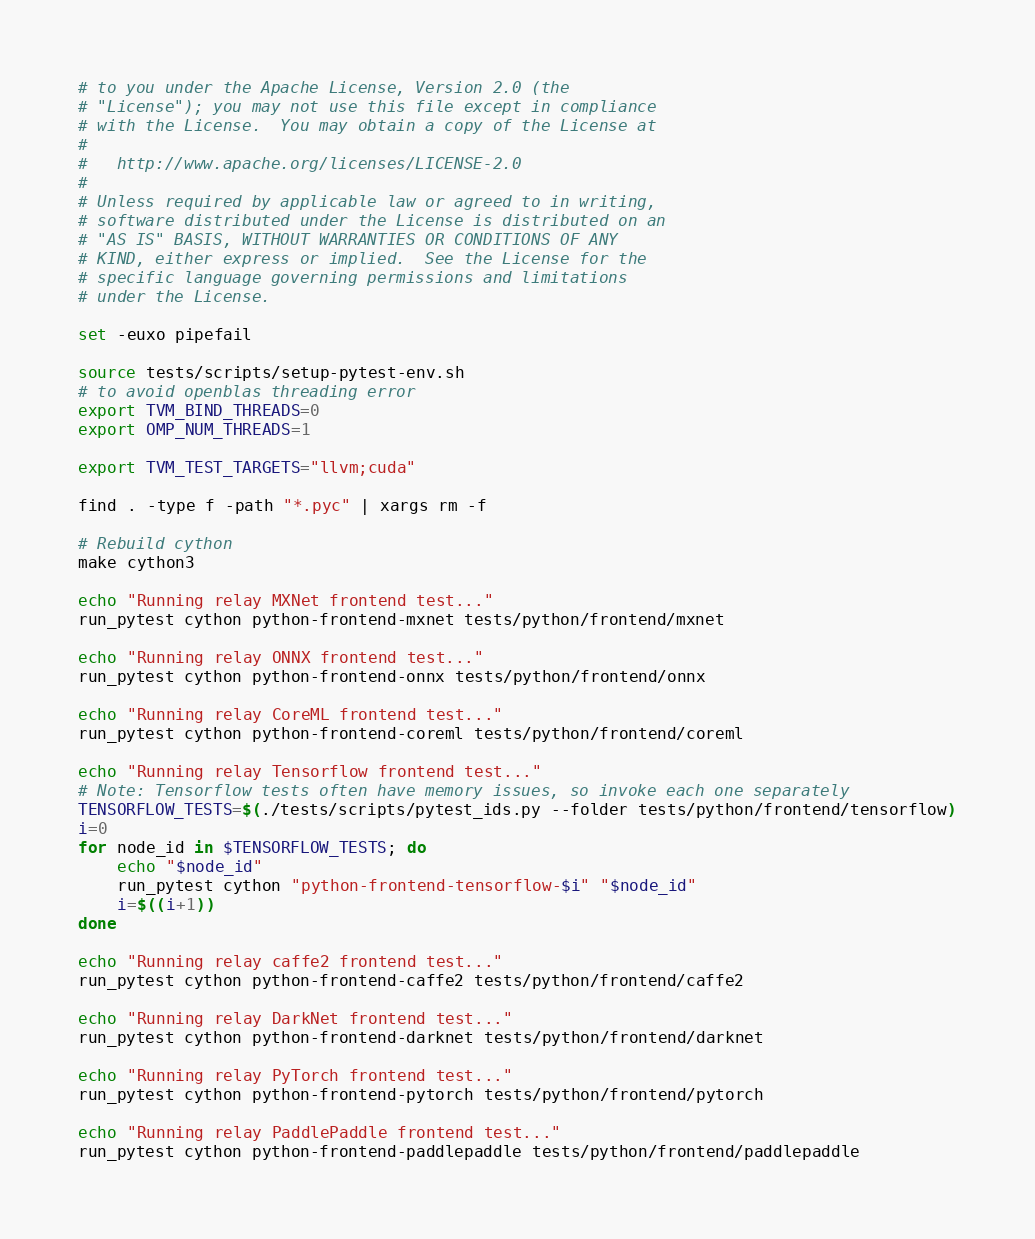<code> <loc_0><loc_0><loc_500><loc_500><_Bash_># to you under the Apache License, Version 2.0 (the
# "License"); you may not use this file except in compliance
# with the License.  You may obtain a copy of the License at
#
#   http://www.apache.org/licenses/LICENSE-2.0
#
# Unless required by applicable law or agreed to in writing,
# software distributed under the License is distributed on an
# "AS IS" BASIS, WITHOUT WARRANTIES OR CONDITIONS OF ANY
# KIND, either express or implied.  See the License for the
# specific language governing permissions and limitations
# under the License.

set -euxo pipefail

source tests/scripts/setup-pytest-env.sh
# to avoid openblas threading error
export TVM_BIND_THREADS=0
export OMP_NUM_THREADS=1

export TVM_TEST_TARGETS="llvm;cuda"

find . -type f -path "*.pyc" | xargs rm -f

# Rebuild cython
make cython3

echo "Running relay MXNet frontend test..."
run_pytest cython python-frontend-mxnet tests/python/frontend/mxnet

echo "Running relay ONNX frontend test..."
run_pytest cython python-frontend-onnx tests/python/frontend/onnx

echo "Running relay CoreML frontend test..."
run_pytest cython python-frontend-coreml tests/python/frontend/coreml

echo "Running relay Tensorflow frontend test..."
# Note: Tensorflow tests often have memory issues, so invoke each one separately
TENSORFLOW_TESTS=$(./tests/scripts/pytest_ids.py --folder tests/python/frontend/tensorflow)
i=0
for node_id in $TENSORFLOW_TESTS; do
    echo "$node_id"
    run_pytest cython "python-frontend-tensorflow-$i" "$node_id"
    i=$((i+1))
done

echo "Running relay caffe2 frontend test..."
run_pytest cython python-frontend-caffe2 tests/python/frontend/caffe2

echo "Running relay DarkNet frontend test..."
run_pytest cython python-frontend-darknet tests/python/frontend/darknet

echo "Running relay PyTorch frontend test..."
run_pytest cython python-frontend-pytorch tests/python/frontend/pytorch

echo "Running relay PaddlePaddle frontend test..."
run_pytest cython python-frontend-paddlepaddle tests/python/frontend/paddlepaddle
</code> 